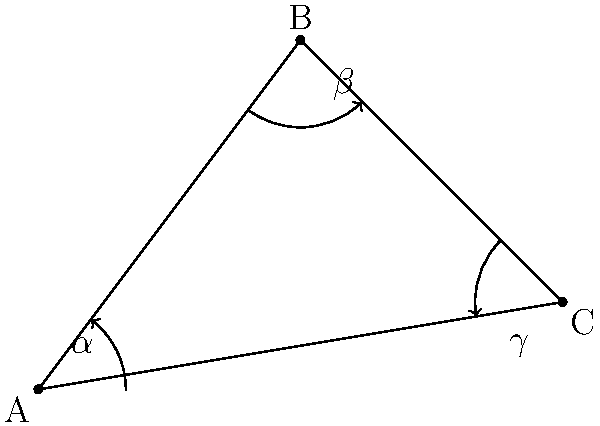In an ancient cave painting, three figures form a triangle with interior angles $\alpha$, $\beta$, and $\gamma$. If $\alpha = 53.13°$ and $\beta = 90°$, what is the measure of $\gamma$ to the nearest degree? To find the measure of $\gamma$, we can follow these steps:

1) Recall that the sum of interior angles in a triangle is always 180°.

2) We can express this as an equation:
   $\alpha + \beta + \gamma = 180°$

3) We know two of the angles:
   $\alpha = 53.13°$
   $\beta = 90°$

4) Substitute these values into the equation:
   $53.13° + 90° + \gamma = 180°$

5) Simplify:
   $143.13° + \gamma = 180°$

6) Subtract 143.13° from both sides:
   $\gamma = 180° - 143.13°$

7) Calculate:
   $\gamma = 36.87°$

8) Round to the nearest degree:
   $\gamma ≈ 37°$

Therefore, the measure of $\gamma$ to the nearest degree is 37°.
Answer: 37° 